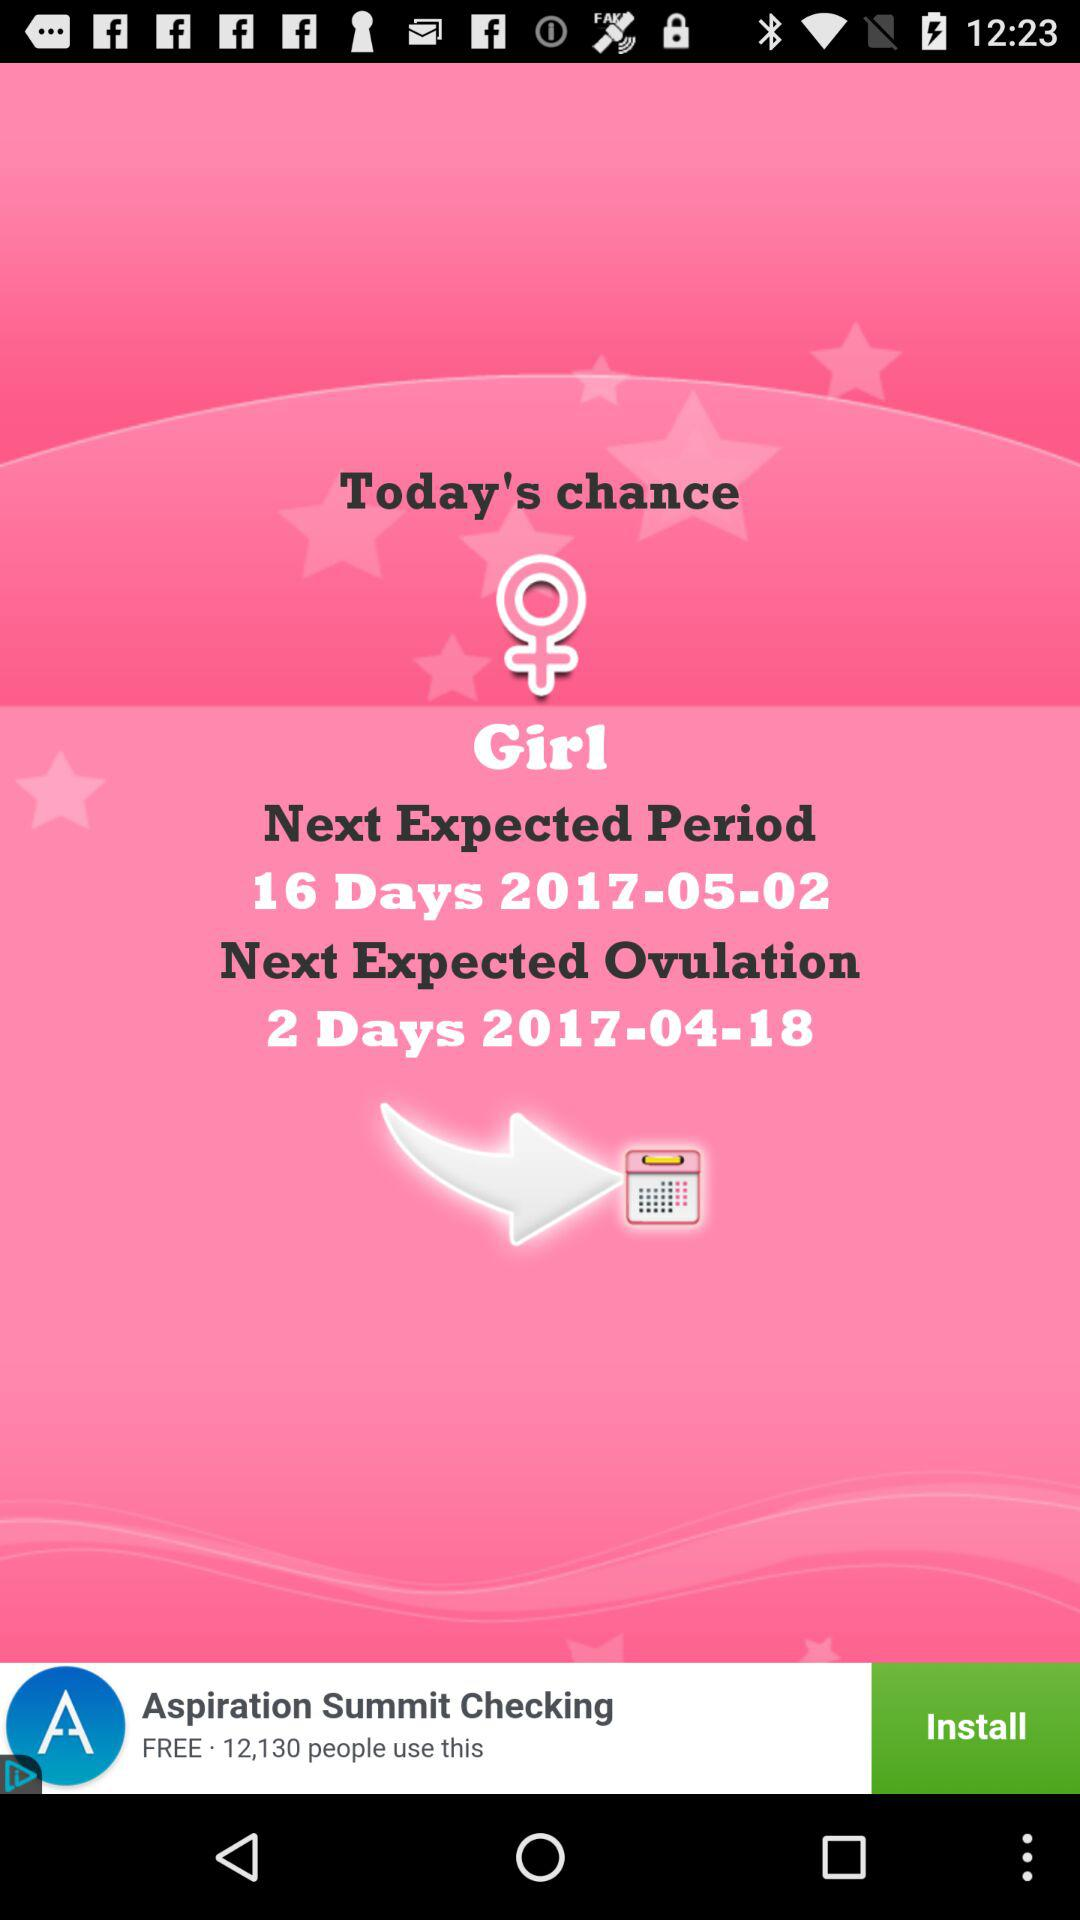What is the gender?
Answer the question using a single word or phrase. It's a girl. 